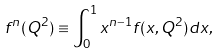Convert formula to latex. <formula><loc_0><loc_0><loc_500><loc_500>f ^ { n } ( Q ^ { 2 } ) \equiv \int ^ { 1 } _ { 0 } x ^ { n - 1 } f ( x , Q ^ { 2 } ) d x \/ ,</formula> 